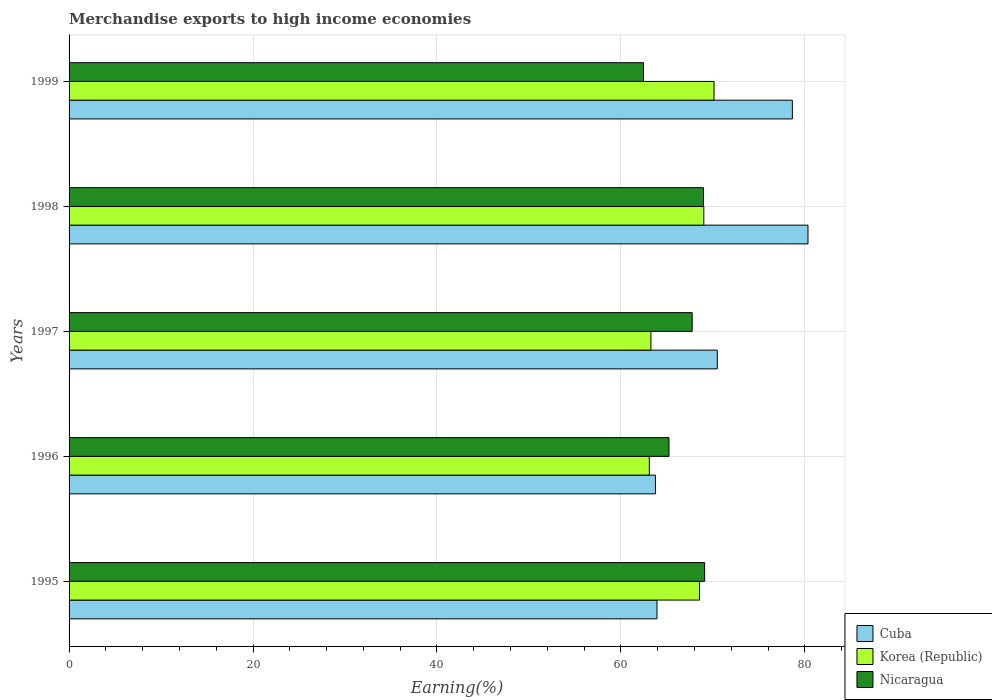How many groups of bars are there?
Make the answer very short. 5. Are the number of bars per tick equal to the number of legend labels?
Give a very brief answer. Yes. Are the number of bars on each tick of the Y-axis equal?
Your response must be concise. Yes. How many bars are there on the 5th tick from the bottom?
Your answer should be compact. 3. What is the label of the 2nd group of bars from the top?
Offer a terse response. 1998. In how many cases, is the number of bars for a given year not equal to the number of legend labels?
Make the answer very short. 0. What is the percentage of amount earned from merchandise exports in Nicaragua in 1997?
Provide a short and direct response. 67.75. Across all years, what is the maximum percentage of amount earned from merchandise exports in Cuba?
Give a very brief answer. 80.34. Across all years, what is the minimum percentage of amount earned from merchandise exports in Korea (Republic)?
Offer a very short reply. 63.09. What is the total percentage of amount earned from merchandise exports in Korea (Republic) in the graph?
Provide a short and direct response. 334.02. What is the difference between the percentage of amount earned from merchandise exports in Cuba in 1998 and that in 1999?
Provide a short and direct response. 1.7. What is the difference between the percentage of amount earned from merchandise exports in Nicaragua in 1997 and the percentage of amount earned from merchandise exports in Korea (Republic) in 1999?
Your answer should be very brief. -2.37. What is the average percentage of amount earned from merchandise exports in Nicaragua per year?
Offer a very short reply. 66.7. In the year 1999, what is the difference between the percentage of amount earned from merchandise exports in Cuba and percentage of amount earned from merchandise exports in Korea (Republic)?
Provide a succinct answer. 8.52. What is the ratio of the percentage of amount earned from merchandise exports in Nicaragua in 1997 to that in 1999?
Offer a very short reply. 1.08. Is the percentage of amount earned from merchandise exports in Nicaragua in 1996 less than that in 1999?
Keep it short and to the point. No. What is the difference between the highest and the second highest percentage of amount earned from merchandise exports in Korea (Republic)?
Ensure brevity in your answer.  1.11. What is the difference between the highest and the lowest percentage of amount earned from merchandise exports in Cuba?
Provide a short and direct response. 16.59. In how many years, is the percentage of amount earned from merchandise exports in Nicaragua greater than the average percentage of amount earned from merchandise exports in Nicaragua taken over all years?
Provide a succinct answer. 3. Is the sum of the percentage of amount earned from merchandise exports in Nicaragua in 1995 and 1998 greater than the maximum percentage of amount earned from merchandise exports in Korea (Republic) across all years?
Offer a very short reply. Yes. What does the 3rd bar from the top in 1999 represents?
Your answer should be compact. Cuba. Are all the bars in the graph horizontal?
Give a very brief answer. Yes. How many years are there in the graph?
Offer a terse response. 5. Does the graph contain any zero values?
Your response must be concise. No. How are the legend labels stacked?
Make the answer very short. Vertical. What is the title of the graph?
Give a very brief answer. Merchandise exports to high income economies. Does "Hong Kong" appear as one of the legend labels in the graph?
Make the answer very short. No. What is the label or title of the X-axis?
Make the answer very short. Earning(%). What is the Earning(%) in Cuba in 1995?
Your answer should be compact. 63.92. What is the Earning(%) of Korea (Republic) in 1995?
Provide a succinct answer. 68.55. What is the Earning(%) of Nicaragua in 1995?
Provide a succinct answer. 69.1. What is the Earning(%) of Cuba in 1996?
Make the answer very short. 63.75. What is the Earning(%) of Korea (Republic) in 1996?
Ensure brevity in your answer.  63.09. What is the Earning(%) in Nicaragua in 1996?
Make the answer very short. 65.22. What is the Earning(%) of Cuba in 1997?
Give a very brief answer. 70.47. What is the Earning(%) of Korea (Republic) in 1997?
Offer a terse response. 63.26. What is the Earning(%) of Nicaragua in 1997?
Provide a short and direct response. 67.75. What is the Earning(%) of Cuba in 1998?
Make the answer very short. 80.34. What is the Earning(%) in Korea (Republic) in 1998?
Make the answer very short. 69.01. What is the Earning(%) of Nicaragua in 1998?
Your answer should be compact. 68.98. What is the Earning(%) in Cuba in 1999?
Make the answer very short. 78.64. What is the Earning(%) in Korea (Republic) in 1999?
Ensure brevity in your answer.  70.12. What is the Earning(%) in Nicaragua in 1999?
Ensure brevity in your answer.  62.45. Across all years, what is the maximum Earning(%) of Cuba?
Provide a succinct answer. 80.34. Across all years, what is the maximum Earning(%) of Korea (Republic)?
Offer a terse response. 70.12. Across all years, what is the maximum Earning(%) of Nicaragua?
Your response must be concise. 69.1. Across all years, what is the minimum Earning(%) of Cuba?
Offer a very short reply. 63.75. Across all years, what is the minimum Earning(%) in Korea (Republic)?
Offer a very short reply. 63.09. Across all years, what is the minimum Earning(%) of Nicaragua?
Your answer should be very brief. 62.45. What is the total Earning(%) in Cuba in the graph?
Your answer should be compact. 357.13. What is the total Earning(%) of Korea (Republic) in the graph?
Give a very brief answer. 334.02. What is the total Earning(%) in Nicaragua in the graph?
Provide a succinct answer. 333.5. What is the difference between the Earning(%) in Cuba in 1995 and that in 1996?
Your response must be concise. 0.17. What is the difference between the Earning(%) of Korea (Republic) in 1995 and that in 1996?
Provide a short and direct response. 5.46. What is the difference between the Earning(%) of Nicaragua in 1995 and that in 1996?
Offer a terse response. 3.88. What is the difference between the Earning(%) of Cuba in 1995 and that in 1997?
Make the answer very short. -6.55. What is the difference between the Earning(%) in Korea (Republic) in 1995 and that in 1997?
Provide a succinct answer. 5.29. What is the difference between the Earning(%) in Nicaragua in 1995 and that in 1997?
Keep it short and to the point. 1.35. What is the difference between the Earning(%) in Cuba in 1995 and that in 1998?
Your answer should be compact. -16.42. What is the difference between the Earning(%) in Korea (Republic) in 1995 and that in 1998?
Keep it short and to the point. -0.46. What is the difference between the Earning(%) in Nicaragua in 1995 and that in 1998?
Keep it short and to the point. 0.12. What is the difference between the Earning(%) in Cuba in 1995 and that in 1999?
Give a very brief answer. -14.71. What is the difference between the Earning(%) in Korea (Republic) in 1995 and that in 1999?
Give a very brief answer. -1.58. What is the difference between the Earning(%) of Nicaragua in 1995 and that in 1999?
Your response must be concise. 6.64. What is the difference between the Earning(%) in Cuba in 1996 and that in 1997?
Provide a succinct answer. -6.72. What is the difference between the Earning(%) in Korea (Republic) in 1996 and that in 1997?
Give a very brief answer. -0.17. What is the difference between the Earning(%) in Nicaragua in 1996 and that in 1997?
Offer a very short reply. -2.52. What is the difference between the Earning(%) in Cuba in 1996 and that in 1998?
Keep it short and to the point. -16.59. What is the difference between the Earning(%) in Korea (Republic) in 1996 and that in 1998?
Keep it short and to the point. -5.93. What is the difference between the Earning(%) in Nicaragua in 1996 and that in 1998?
Offer a very short reply. -3.76. What is the difference between the Earning(%) of Cuba in 1996 and that in 1999?
Give a very brief answer. -14.89. What is the difference between the Earning(%) in Korea (Republic) in 1996 and that in 1999?
Your response must be concise. -7.04. What is the difference between the Earning(%) in Nicaragua in 1996 and that in 1999?
Make the answer very short. 2.77. What is the difference between the Earning(%) in Cuba in 1997 and that in 1998?
Ensure brevity in your answer.  -9.86. What is the difference between the Earning(%) in Korea (Republic) in 1997 and that in 1998?
Make the answer very short. -5.75. What is the difference between the Earning(%) of Nicaragua in 1997 and that in 1998?
Your response must be concise. -1.23. What is the difference between the Earning(%) of Cuba in 1997 and that in 1999?
Offer a very short reply. -8.16. What is the difference between the Earning(%) in Korea (Republic) in 1997 and that in 1999?
Keep it short and to the point. -6.86. What is the difference between the Earning(%) in Nicaragua in 1997 and that in 1999?
Provide a short and direct response. 5.29. What is the difference between the Earning(%) in Cuba in 1998 and that in 1999?
Make the answer very short. 1.7. What is the difference between the Earning(%) in Korea (Republic) in 1998 and that in 1999?
Offer a very short reply. -1.11. What is the difference between the Earning(%) of Nicaragua in 1998 and that in 1999?
Provide a succinct answer. 6.53. What is the difference between the Earning(%) of Cuba in 1995 and the Earning(%) of Korea (Republic) in 1996?
Ensure brevity in your answer.  0.84. What is the difference between the Earning(%) of Cuba in 1995 and the Earning(%) of Nicaragua in 1996?
Your response must be concise. -1.3. What is the difference between the Earning(%) of Korea (Republic) in 1995 and the Earning(%) of Nicaragua in 1996?
Offer a terse response. 3.32. What is the difference between the Earning(%) in Cuba in 1995 and the Earning(%) in Korea (Republic) in 1997?
Keep it short and to the point. 0.66. What is the difference between the Earning(%) of Cuba in 1995 and the Earning(%) of Nicaragua in 1997?
Your response must be concise. -3.82. What is the difference between the Earning(%) in Korea (Republic) in 1995 and the Earning(%) in Nicaragua in 1997?
Ensure brevity in your answer.  0.8. What is the difference between the Earning(%) in Cuba in 1995 and the Earning(%) in Korea (Republic) in 1998?
Provide a succinct answer. -5.09. What is the difference between the Earning(%) in Cuba in 1995 and the Earning(%) in Nicaragua in 1998?
Ensure brevity in your answer.  -5.06. What is the difference between the Earning(%) in Korea (Republic) in 1995 and the Earning(%) in Nicaragua in 1998?
Your answer should be compact. -0.43. What is the difference between the Earning(%) of Cuba in 1995 and the Earning(%) of Korea (Republic) in 1999?
Offer a very short reply. -6.2. What is the difference between the Earning(%) of Cuba in 1995 and the Earning(%) of Nicaragua in 1999?
Give a very brief answer. 1.47. What is the difference between the Earning(%) of Korea (Republic) in 1995 and the Earning(%) of Nicaragua in 1999?
Your answer should be compact. 6.09. What is the difference between the Earning(%) in Cuba in 1996 and the Earning(%) in Korea (Republic) in 1997?
Give a very brief answer. 0.49. What is the difference between the Earning(%) of Cuba in 1996 and the Earning(%) of Nicaragua in 1997?
Your answer should be very brief. -4. What is the difference between the Earning(%) of Korea (Republic) in 1996 and the Earning(%) of Nicaragua in 1997?
Provide a short and direct response. -4.66. What is the difference between the Earning(%) of Cuba in 1996 and the Earning(%) of Korea (Republic) in 1998?
Your response must be concise. -5.26. What is the difference between the Earning(%) in Cuba in 1996 and the Earning(%) in Nicaragua in 1998?
Offer a terse response. -5.23. What is the difference between the Earning(%) in Korea (Republic) in 1996 and the Earning(%) in Nicaragua in 1998?
Make the answer very short. -5.9. What is the difference between the Earning(%) in Cuba in 1996 and the Earning(%) in Korea (Republic) in 1999?
Ensure brevity in your answer.  -6.37. What is the difference between the Earning(%) of Cuba in 1996 and the Earning(%) of Nicaragua in 1999?
Provide a short and direct response. 1.3. What is the difference between the Earning(%) of Korea (Republic) in 1996 and the Earning(%) of Nicaragua in 1999?
Provide a succinct answer. 0.63. What is the difference between the Earning(%) in Cuba in 1997 and the Earning(%) in Korea (Republic) in 1998?
Your response must be concise. 1.46. What is the difference between the Earning(%) of Cuba in 1997 and the Earning(%) of Nicaragua in 1998?
Provide a succinct answer. 1.49. What is the difference between the Earning(%) of Korea (Republic) in 1997 and the Earning(%) of Nicaragua in 1998?
Provide a succinct answer. -5.72. What is the difference between the Earning(%) in Cuba in 1997 and the Earning(%) in Korea (Republic) in 1999?
Make the answer very short. 0.35. What is the difference between the Earning(%) of Cuba in 1997 and the Earning(%) of Nicaragua in 1999?
Your answer should be very brief. 8.02. What is the difference between the Earning(%) in Korea (Republic) in 1997 and the Earning(%) in Nicaragua in 1999?
Ensure brevity in your answer.  0.8. What is the difference between the Earning(%) in Cuba in 1998 and the Earning(%) in Korea (Republic) in 1999?
Make the answer very short. 10.22. What is the difference between the Earning(%) in Cuba in 1998 and the Earning(%) in Nicaragua in 1999?
Your answer should be compact. 17.88. What is the difference between the Earning(%) of Korea (Republic) in 1998 and the Earning(%) of Nicaragua in 1999?
Make the answer very short. 6.56. What is the average Earning(%) in Cuba per year?
Ensure brevity in your answer.  71.43. What is the average Earning(%) in Korea (Republic) per year?
Offer a very short reply. 66.8. What is the average Earning(%) of Nicaragua per year?
Make the answer very short. 66.7. In the year 1995, what is the difference between the Earning(%) of Cuba and Earning(%) of Korea (Republic)?
Give a very brief answer. -4.62. In the year 1995, what is the difference between the Earning(%) of Cuba and Earning(%) of Nicaragua?
Provide a short and direct response. -5.18. In the year 1995, what is the difference between the Earning(%) of Korea (Republic) and Earning(%) of Nicaragua?
Give a very brief answer. -0.55. In the year 1996, what is the difference between the Earning(%) in Cuba and Earning(%) in Nicaragua?
Your answer should be very brief. -1.47. In the year 1996, what is the difference between the Earning(%) in Korea (Republic) and Earning(%) in Nicaragua?
Make the answer very short. -2.14. In the year 1997, what is the difference between the Earning(%) of Cuba and Earning(%) of Korea (Republic)?
Offer a very short reply. 7.22. In the year 1997, what is the difference between the Earning(%) of Cuba and Earning(%) of Nicaragua?
Ensure brevity in your answer.  2.73. In the year 1997, what is the difference between the Earning(%) of Korea (Republic) and Earning(%) of Nicaragua?
Offer a terse response. -4.49. In the year 1998, what is the difference between the Earning(%) in Cuba and Earning(%) in Korea (Republic)?
Ensure brevity in your answer.  11.33. In the year 1998, what is the difference between the Earning(%) of Cuba and Earning(%) of Nicaragua?
Your answer should be very brief. 11.36. In the year 1998, what is the difference between the Earning(%) of Korea (Republic) and Earning(%) of Nicaragua?
Ensure brevity in your answer.  0.03. In the year 1999, what is the difference between the Earning(%) of Cuba and Earning(%) of Korea (Republic)?
Your answer should be compact. 8.52. In the year 1999, what is the difference between the Earning(%) of Cuba and Earning(%) of Nicaragua?
Ensure brevity in your answer.  16.18. In the year 1999, what is the difference between the Earning(%) in Korea (Republic) and Earning(%) in Nicaragua?
Give a very brief answer. 7.67. What is the ratio of the Earning(%) in Cuba in 1995 to that in 1996?
Provide a succinct answer. 1. What is the ratio of the Earning(%) of Korea (Republic) in 1995 to that in 1996?
Offer a very short reply. 1.09. What is the ratio of the Earning(%) of Nicaragua in 1995 to that in 1996?
Provide a succinct answer. 1.06. What is the ratio of the Earning(%) in Cuba in 1995 to that in 1997?
Offer a terse response. 0.91. What is the ratio of the Earning(%) in Korea (Republic) in 1995 to that in 1997?
Give a very brief answer. 1.08. What is the ratio of the Earning(%) in Nicaragua in 1995 to that in 1997?
Make the answer very short. 1.02. What is the ratio of the Earning(%) in Cuba in 1995 to that in 1998?
Your answer should be compact. 0.8. What is the ratio of the Earning(%) of Cuba in 1995 to that in 1999?
Make the answer very short. 0.81. What is the ratio of the Earning(%) of Korea (Republic) in 1995 to that in 1999?
Your answer should be very brief. 0.98. What is the ratio of the Earning(%) of Nicaragua in 1995 to that in 1999?
Ensure brevity in your answer.  1.11. What is the ratio of the Earning(%) of Cuba in 1996 to that in 1997?
Give a very brief answer. 0.9. What is the ratio of the Earning(%) in Korea (Republic) in 1996 to that in 1997?
Give a very brief answer. 1. What is the ratio of the Earning(%) in Nicaragua in 1996 to that in 1997?
Keep it short and to the point. 0.96. What is the ratio of the Earning(%) of Cuba in 1996 to that in 1998?
Provide a short and direct response. 0.79. What is the ratio of the Earning(%) of Korea (Republic) in 1996 to that in 1998?
Offer a very short reply. 0.91. What is the ratio of the Earning(%) of Nicaragua in 1996 to that in 1998?
Provide a short and direct response. 0.95. What is the ratio of the Earning(%) in Cuba in 1996 to that in 1999?
Make the answer very short. 0.81. What is the ratio of the Earning(%) in Korea (Republic) in 1996 to that in 1999?
Ensure brevity in your answer.  0.9. What is the ratio of the Earning(%) in Nicaragua in 1996 to that in 1999?
Provide a succinct answer. 1.04. What is the ratio of the Earning(%) of Cuba in 1997 to that in 1998?
Your answer should be very brief. 0.88. What is the ratio of the Earning(%) of Korea (Republic) in 1997 to that in 1998?
Offer a terse response. 0.92. What is the ratio of the Earning(%) in Nicaragua in 1997 to that in 1998?
Give a very brief answer. 0.98. What is the ratio of the Earning(%) of Cuba in 1997 to that in 1999?
Offer a very short reply. 0.9. What is the ratio of the Earning(%) in Korea (Republic) in 1997 to that in 1999?
Your answer should be compact. 0.9. What is the ratio of the Earning(%) in Nicaragua in 1997 to that in 1999?
Provide a short and direct response. 1.08. What is the ratio of the Earning(%) of Cuba in 1998 to that in 1999?
Ensure brevity in your answer.  1.02. What is the ratio of the Earning(%) of Korea (Republic) in 1998 to that in 1999?
Your answer should be very brief. 0.98. What is the ratio of the Earning(%) in Nicaragua in 1998 to that in 1999?
Your answer should be compact. 1.1. What is the difference between the highest and the second highest Earning(%) in Cuba?
Ensure brevity in your answer.  1.7. What is the difference between the highest and the second highest Earning(%) in Korea (Republic)?
Make the answer very short. 1.11. What is the difference between the highest and the second highest Earning(%) of Nicaragua?
Keep it short and to the point. 0.12. What is the difference between the highest and the lowest Earning(%) in Cuba?
Offer a very short reply. 16.59. What is the difference between the highest and the lowest Earning(%) in Korea (Republic)?
Ensure brevity in your answer.  7.04. What is the difference between the highest and the lowest Earning(%) of Nicaragua?
Offer a terse response. 6.64. 